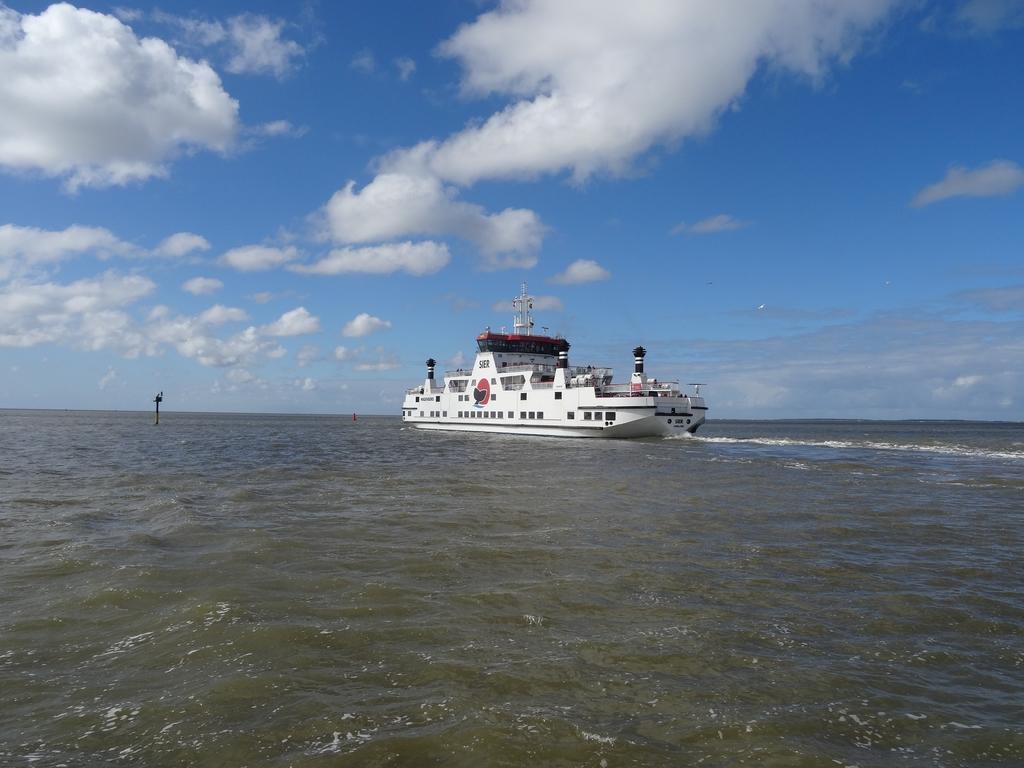In one or two sentences, can you explain what this image depicts? In this image, we can see water, there is a ship on the water, at the top there is a blue sky and we can see some clouds. 